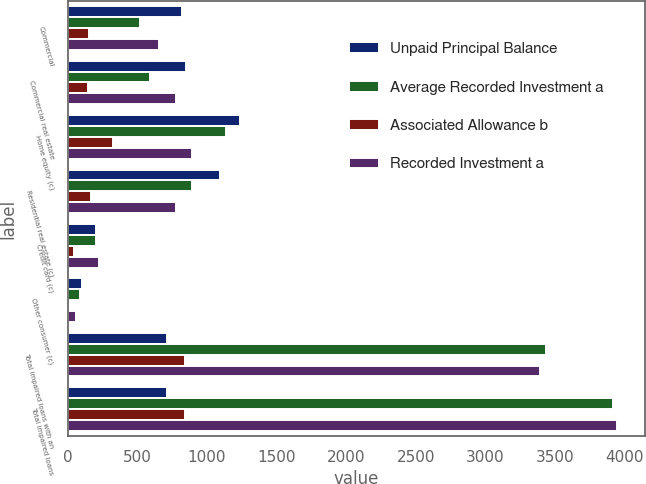Convert chart. <chart><loc_0><loc_0><loc_500><loc_500><stacked_bar_chart><ecel><fcel>Commercial<fcel>Commercial real estate<fcel>Home equity (c)<fcel>Residential real estate (c)<fcel>Credit card (c)<fcel>Other consumer (c)<fcel>Total impaired loans with an<fcel>Total impaired loans<nl><fcel>Unpaid Principal Balance<fcel>824<fcel>851<fcel>1239<fcel>1094<fcel>204<fcel>104<fcel>715<fcel>715<nl><fcel>Average Recorded Investment a<fcel>523<fcel>594<fcel>1134<fcel>894<fcel>204<fcel>86<fcel>3435<fcel>3916<nl><fcel>Associated Allowance b<fcel>150<fcel>143<fcel>328<fcel>168<fcel>48<fcel>3<fcel>840<fcel>840<nl><fcel>Recorded Investment a<fcel>653<fcel>778<fcel>891<fcel>777<fcel>227<fcel>63<fcel>3389<fcel>3946<nl></chart> 